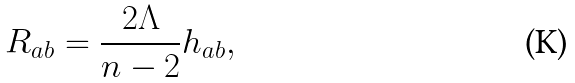Convert formula to latex. <formula><loc_0><loc_0><loc_500><loc_500>R _ { a b } = \frac { 2 \Lambda } { n - 2 } h _ { a b } ,</formula> 